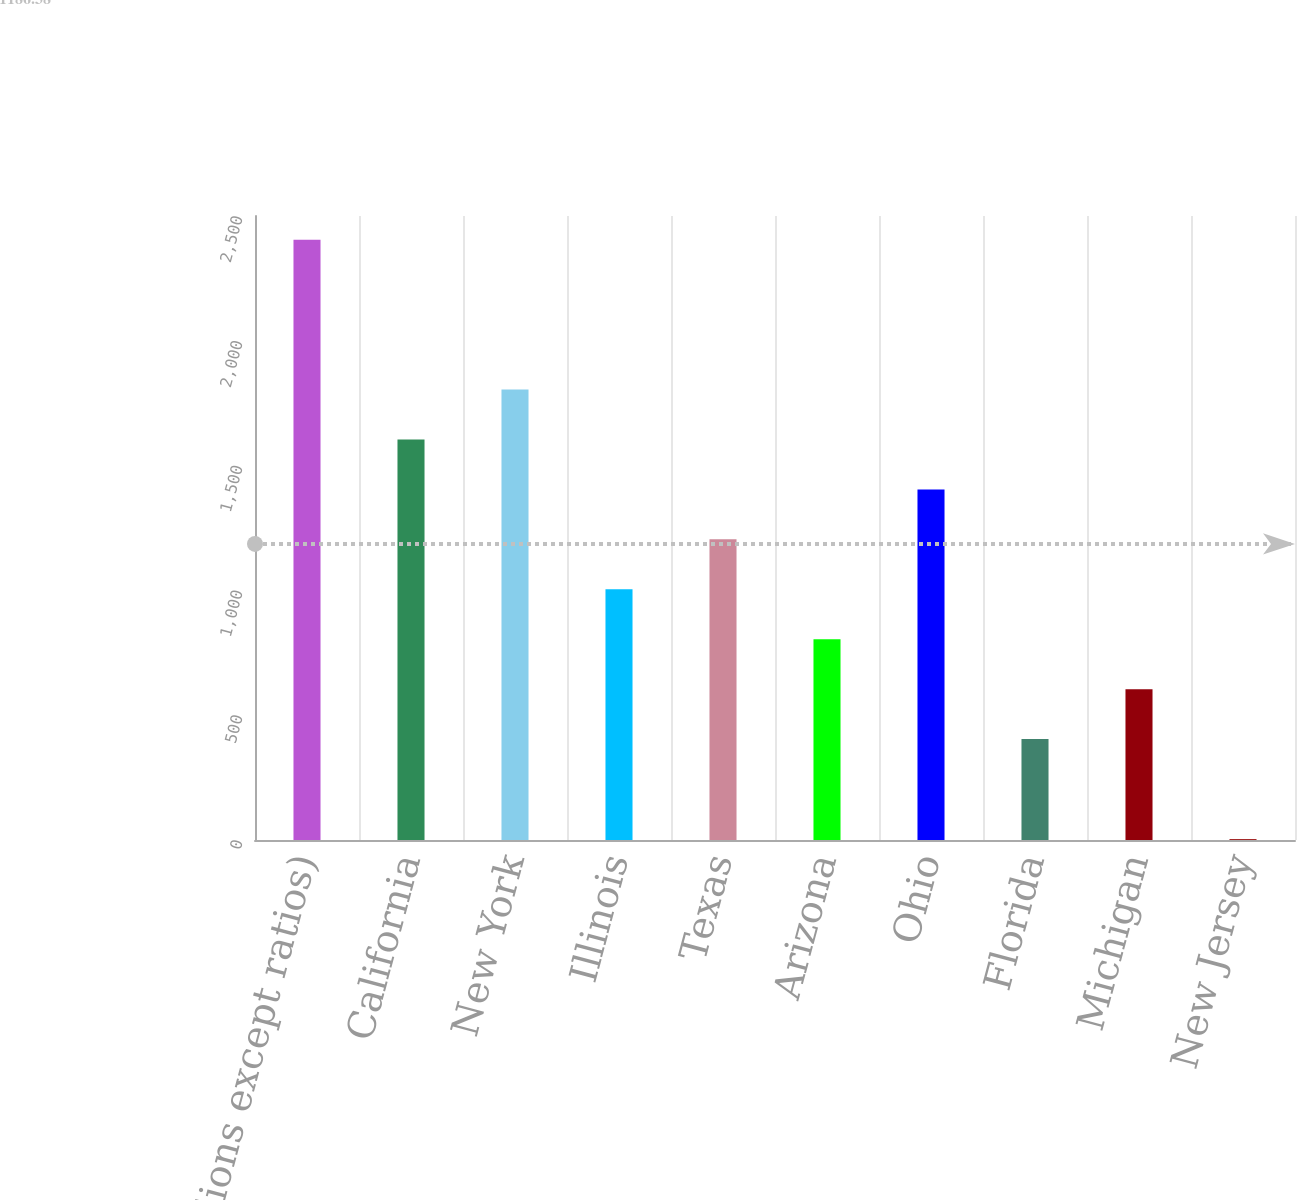Convert chart. <chart><loc_0><loc_0><loc_500><loc_500><bar_chart><fcel>(in billions except ratios)<fcel>California<fcel>New York<fcel>Illinois<fcel>Texas<fcel>Arizona<fcel>Ohio<fcel>Florida<fcel>Michigan<fcel>New Jersey<nl><fcel>2405.2<fcel>1604.8<fcel>1804.9<fcel>1004.5<fcel>1204.6<fcel>804.4<fcel>1404.7<fcel>404.2<fcel>604.3<fcel>4<nl></chart> 